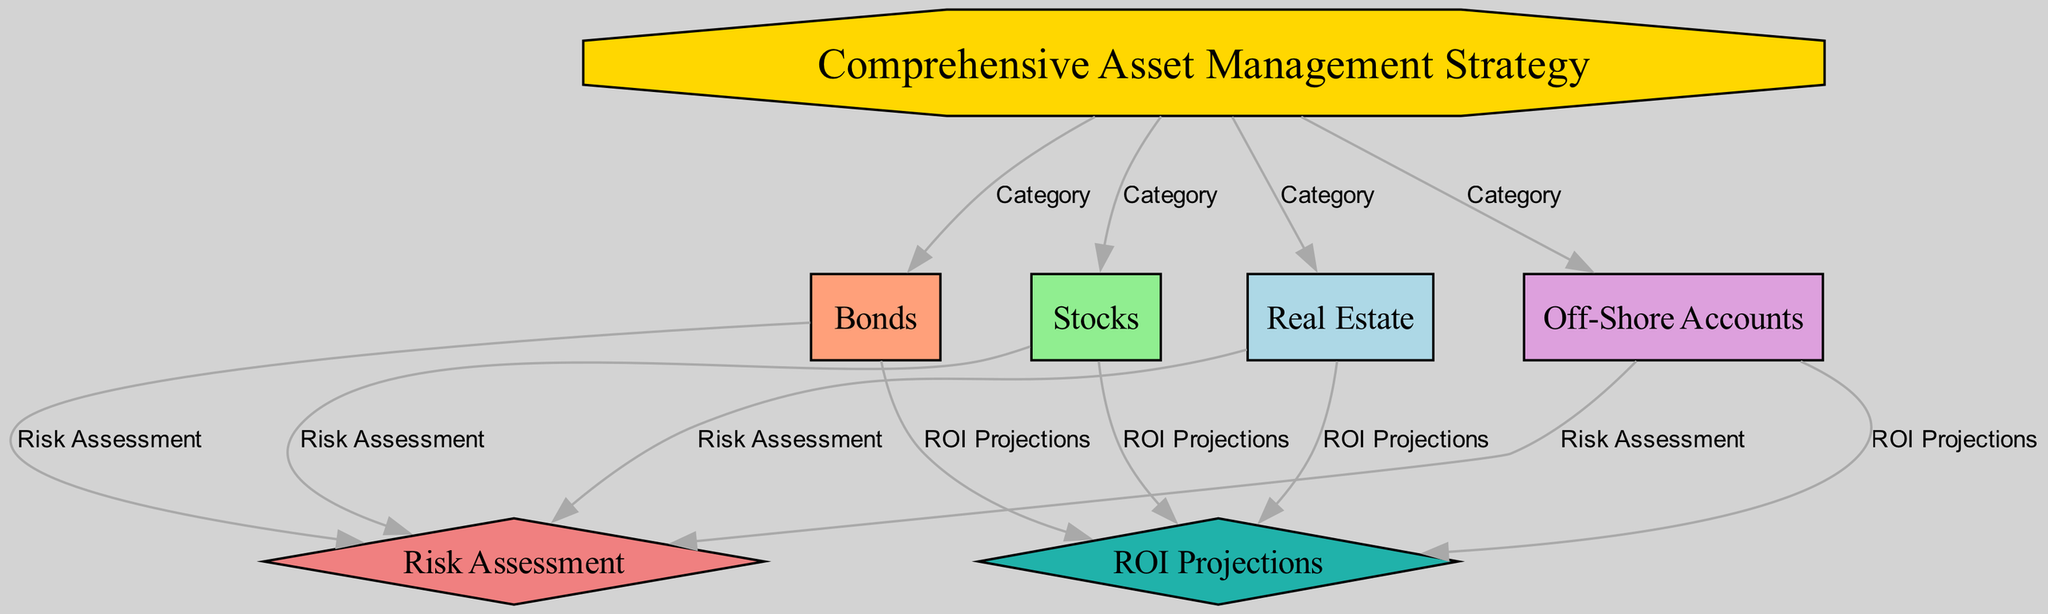What is the central node of the diagram? The central node is the one labeled "Comprehensive Asset Management Strategy," which serves as the main focus of the diagram.
Answer: Comprehensive Asset Management Strategy How many asset categories are presented in the diagram? The diagram features four distinct asset categories: Real Estate, Stocks, Bonds, and Off-Shore Accounts, all branching from the central strategy node.
Answer: Four Which nodes have a direct relationship with "Risk Assessment"? The nodes that directly connect to "Risk Assessment" are Real Estate, Stocks, Bonds, and Off-Shore Accounts, indicating that all these asset categories undergo risk assessment.
Answer: Real Estate, Stocks, Bonds, Off-Shore Accounts What color is associated with the "ROI Projections" node? The node "ROI Projections" is represented in lightseagreen, which distinguishes it visually from other elements in the diagram.
Answer: Lightseagreen Which asset category is connected to both "Risk Assessment" and "ROI Projections"? Real Estate, Stocks, Bonds, and Off-Shore Accounts are all connected to both "Risk Assessment" and "ROI Projections," illustrating that each asset category is evaluated in terms of risk and return.
Answer: Real Estate, Stocks, Bonds, Off-Shore Accounts Which type of shape is used for the "Comprehensive Asset Management Strategy" node? The "Comprehensive Asset Management Strategy" node has the shape of an octagon, which signifies its importance within the diagram.
Answer: Octagon How many edges connect the asset categories to the central strategy node? There are four edges connecting each of the asset categories (Real Estate, Stocks, Bonds, and Off-Shore Accounts) to the central strategy node, illustrating their relationship.
Answer: Four What is the main purpose of the "Risk Assessment" node? The "Risk Assessment" node serves the purpose of evaluating the potential risks associated with each asset category, ensuring a comprehensive understanding of their investment safety.
Answer: Evaluating risks Which node is illustrated as a diamond? Both "Risk Assessment" and "ROI Projections" nodes are illustrated as diamonds, which indicates that they are critical concepts that evaluate performance related to the asset categories.
Answer: Risk Assessment, ROI Projections 